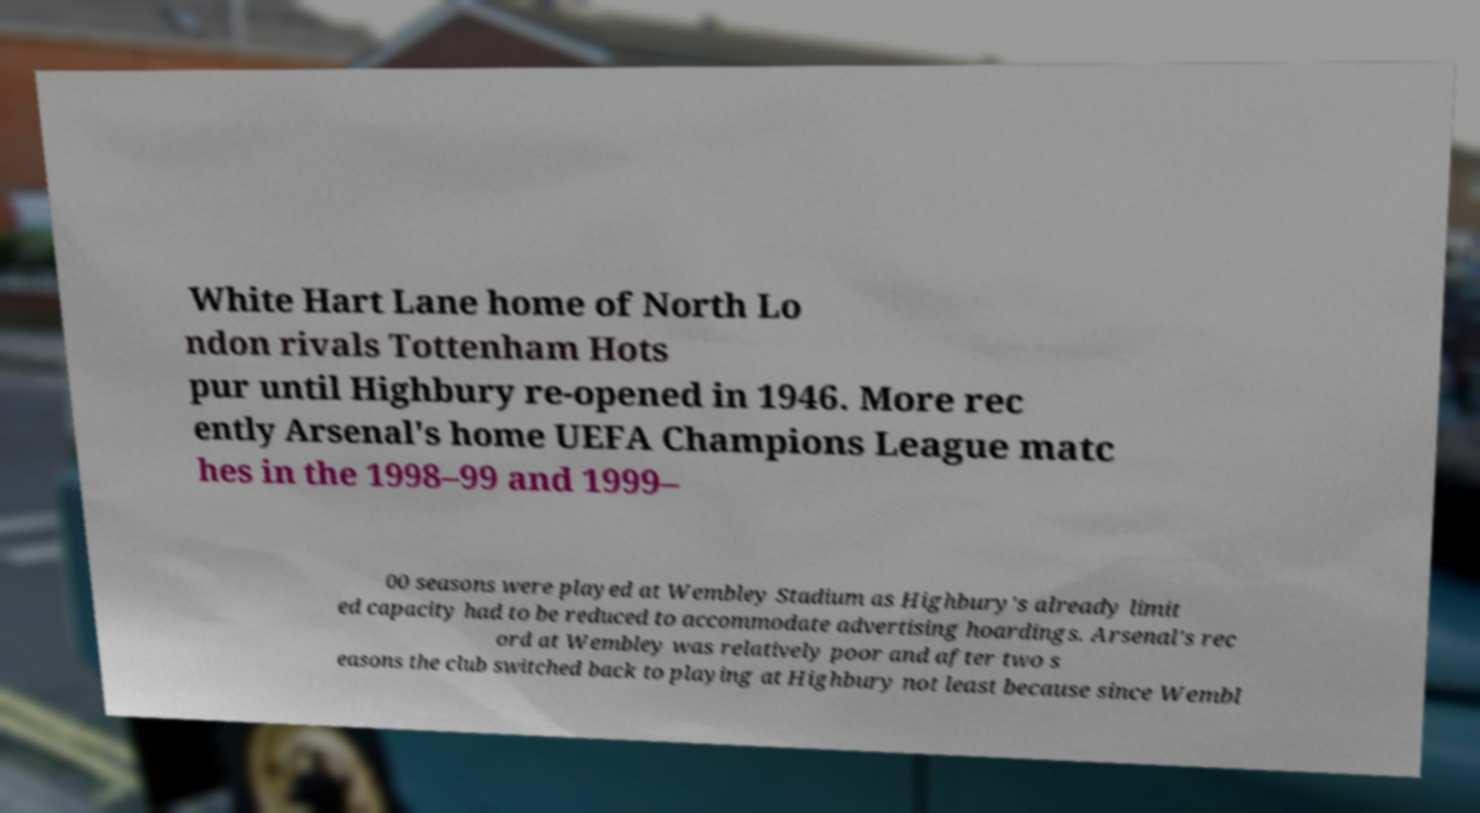Can you read and provide the text displayed in the image?This photo seems to have some interesting text. Can you extract and type it out for me? White Hart Lane home of North Lo ndon rivals Tottenham Hots pur until Highbury re-opened in 1946. More rec ently Arsenal's home UEFA Champions League matc hes in the 1998–99 and 1999– 00 seasons were played at Wembley Stadium as Highbury's already limit ed capacity had to be reduced to accommodate advertising hoardings. Arsenal's rec ord at Wembley was relatively poor and after two s easons the club switched back to playing at Highbury not least because since Wembl 